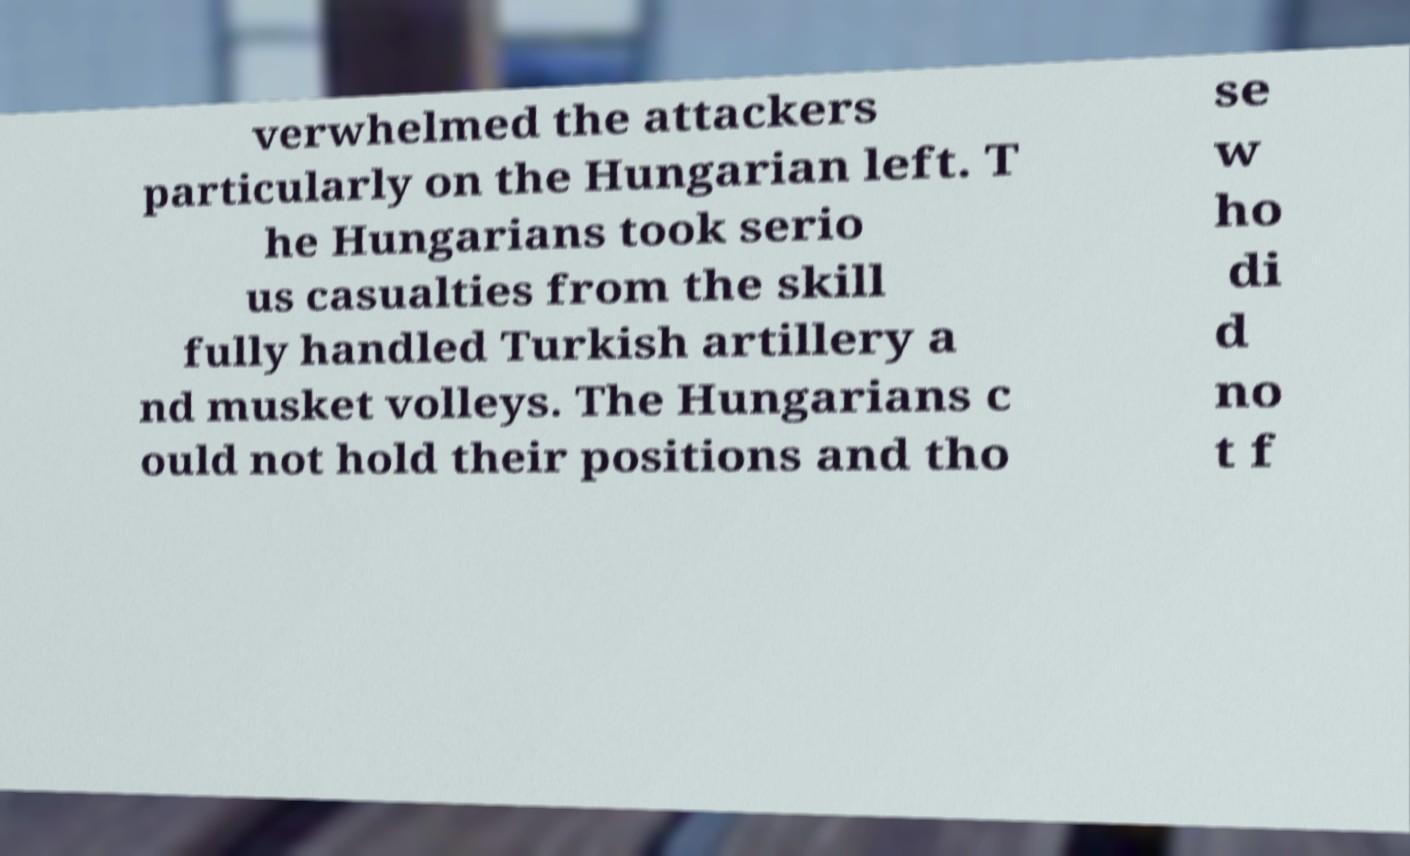Please identify and transcribe the text found in this image. verwhelmed the attackers particularly on the Hungarian left. T he Hungarians took serio us casualties from the skill fully handled Turkish artillery a nd musket volleys. The Hungarians c ould not hold their positions and tho se w ho di d no t f 